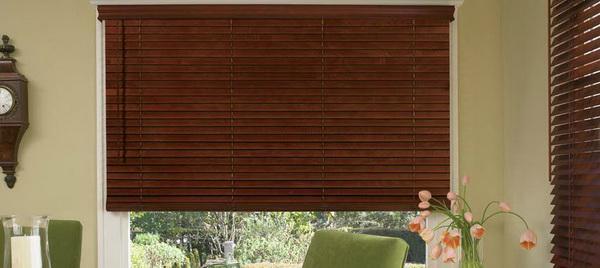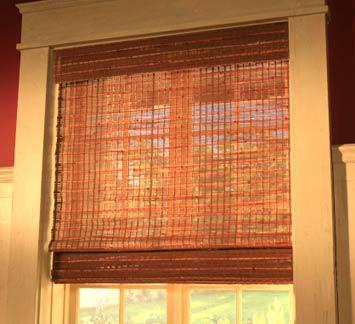The first image is the image on the left, the second image is the image on the right. Examine the images to the left and right. Is the description "In the image to the left, some chairs are visible in front of the window." accurate? Answer yes or no. Yes. 